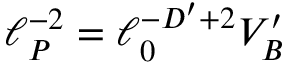<formula> <loc_0><loc_0><loc_500><loc_500>\ell _ { P } ^ { - 2 } = \ell _ { 0 } ^ { - D ^ { \prime } + 2 } V _ { B } ^ { \prime }</formula> 